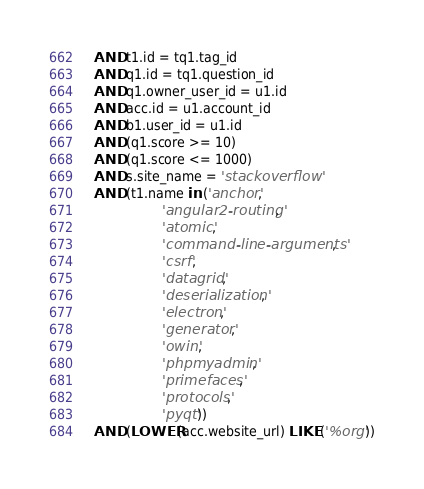<code> <loc_0><loc_0><loc_500><loc_500><_SQL_>  AND t1.id = tq1.tag_id
  AND q1.id = tq1.question_id
  AND q1.owner_user_id = u1.id
  AND acc.id = u1.account_id
  AND b1.user_id = u1.id
  AND (q1.score >= 10)
  AND (q1.score <= 1000)
  AND s.site_name = 'stackoverflow'
  AND (t1.name in ('anchor',
                   'angular2-routing',
                   'atomic',
                   'command-line-arguments',
                   'csrf',
                   'datagrid',
                   'deserialization',
                   'electron',
                   'generator',
                   'owin',
                   'phpmyadmin',
                   'primefaces',
                   'protocols',
                   'pyqt'))
  AND (LOWER(acc.website_url) LIKE ('%org'))</code> 